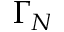<formula> <loc_0><loc_0><loc_500><loc_500>\Gamma _ { N }</formula> 